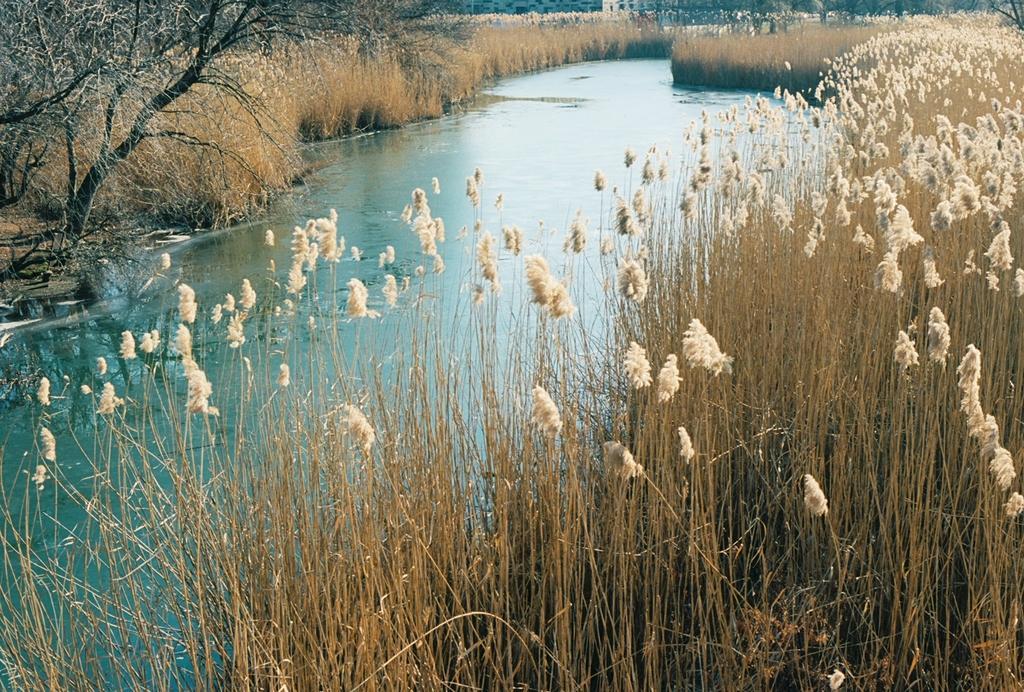Can you describe this image briefly? In this image there is a lake , on either side of the lake there is grass and there is a plant. 